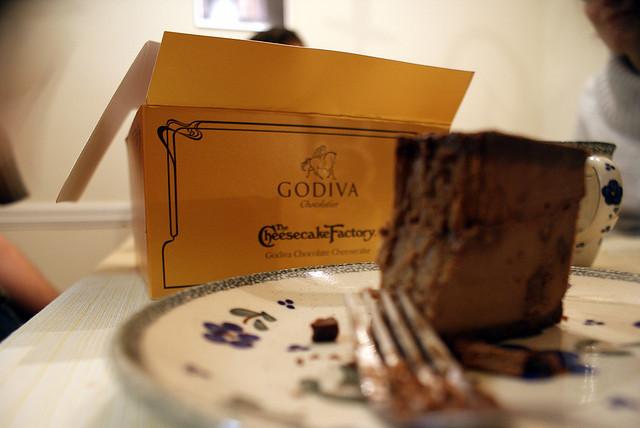What restaurant did the dessert come from?
Give a very brief answer. Cheesecake factory. Is this a famous chocolate?
Give a very brief answer. Yes. How much dessert is left?
Keep it brief. Slice. 